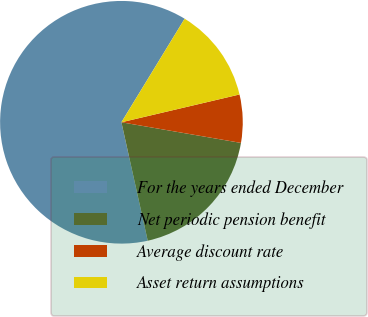Convert chart. <chart><loc_0><loc_0><loc_500><loc_500><pie_chart><fcel>For the years ended December<fcel>Net periodic pension benefit<fcel>Average discount rate<fcel>Asset return assumptions<nl><fcel>62.21%<fcel>18.8%<fcel>6.4%<fcel>12.6%<nl></chart> 